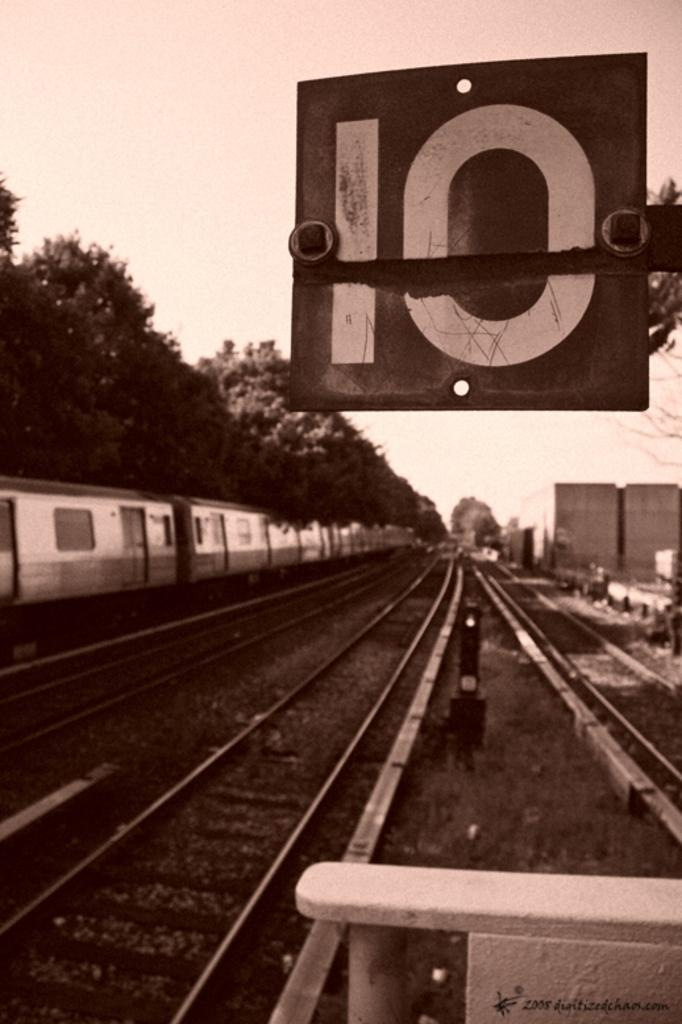<image>
Summarize the visual content of the image. A sign for the number 10 is displayed in front of railway tracks. 